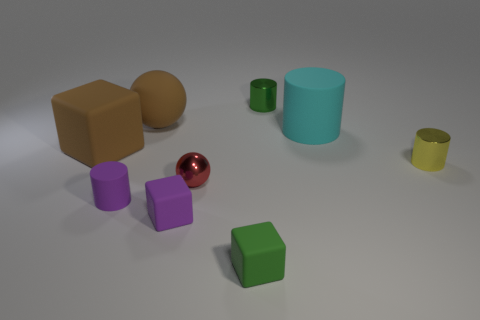Subtract 1 cylinders. How many cylinders are left? 3 Subtract all cylinders. How many objects are left? 5 Subtract 0 yellow spheres. How many objects are left? 9 Subtract all cyan matte cylinders. Subtract all tiny green cylinders. How many objects are left? 7 Add 9 cyan matte objects. How many cyan matte objects are left? 10 Add 2 matte things. How many matte things exist? 8 